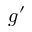Convert formula to latex. <formula><loc_0><loc_0><loc_500><loc_500>g ^ { \prime }</formula> 